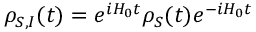<formula> <loc_0><loc_0><loc_500><loc_500>\rho _ { S , I } ( t ) = e ^ { i H _ { 0 } t } \rho _ { S } ( t ) e ^ { - i H _ { 0 } t }</formula> 